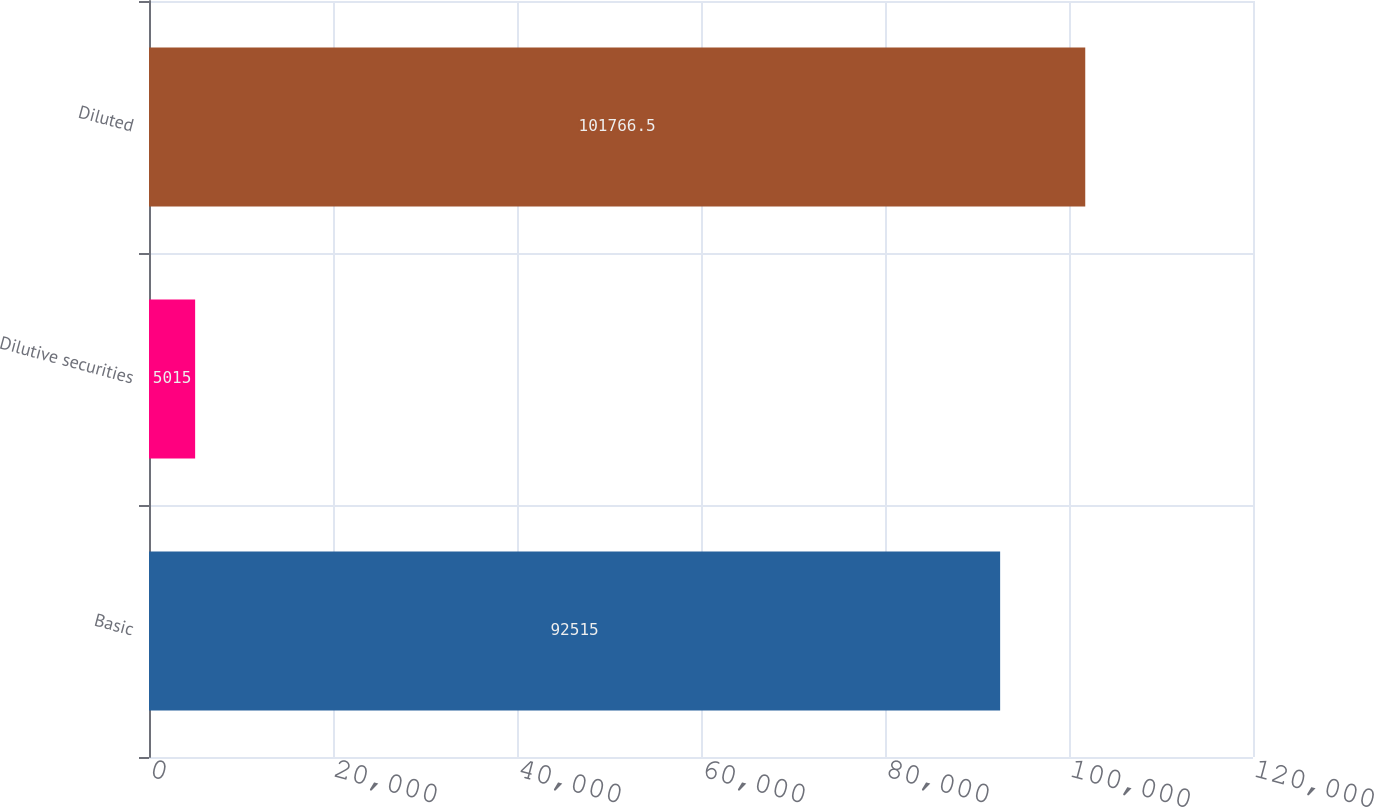<chart> <loc_0><loc_0><loc_500><loc_500><bar_chart><fcel>Basic<fcel>Dilutive securities<fcel>Diluted<nl><fcel>92515<fcel>5015<fcel>101766<nl></chart> 